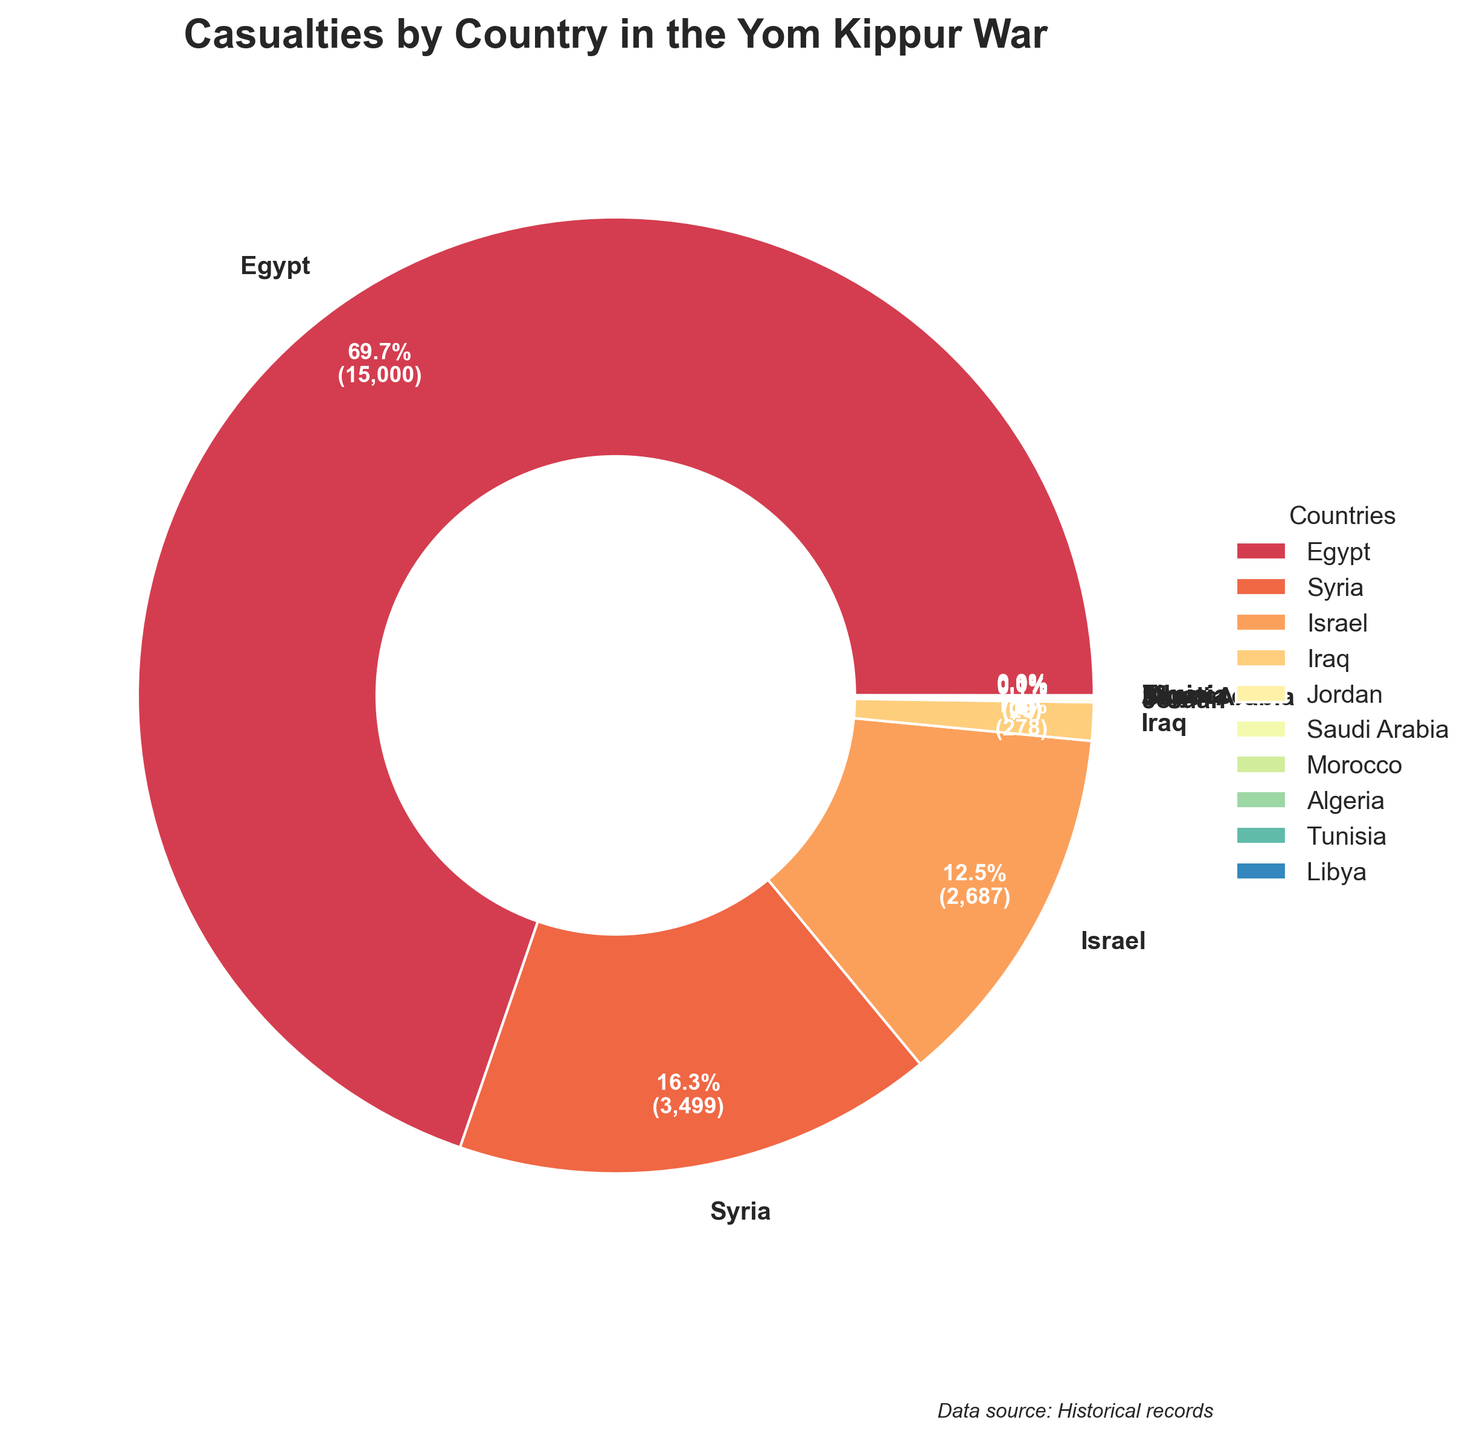Which country had the highest number of casualties? By looking at the pie chart, the largest segment should correspond to the country with the most casualties. The largest segment is labeled "Egypt."
Answer: Egypt How many more casualties did Syria have compared to Iraq? The pie chart shows Syria had 3,500 casualties, and Iraq had 278 casualties. To find the difference, subtract the number of casualties of Iraq from those of Syria: 3,500 - 278 = 3,222.
Answer: 3,222 What's the combined percentage of casualties from Israel and Syria? From the pie chart, Israel had 2,688 casualties, and Syria had 3,500 casualties. Adding them together: 2,688 + 3,500 = 6,188. The total casualties are 21,515. To find the combined percentage: (6,188 / 21,515) * 100 ≈ 28.8%.
Answer: 28.8% What is the percentage of casualties from Iraq? The pie chart displays percentages. Locate Iraq's segment, which shows the percentage directly. Iraq’s segment shows 1.3%.
Answer: 1.3% Which country contributed the least number of casualties, and how many? Refer to the smallest segment in the pie chart. The smallest segment is labeled "Libya," and it has 2 casualties.
Answer: Libya, 2 Which country had fewer casualties, Jordan or Algeria? Compare the sizes of the segments labeled "Jordan" and "Algeria". Jordan had 23 casualties, while Algeria had 5 casualties.
Answer: Algeria How does the percentage of Saudi Arabia’s casualties compare to that of Morocco’s? Locate the segments for "Saudi Arabia" and "Morocco" and compare their percentages. Saudi Arabia had a larger segment with 10 casualties compared to Morocco with 6 casualties, resulting in Saudi Arabia having a higher percentage.
Answer: Saudi Arabia What is the total percentage of casualties contributed by the countries with less than 100 casualties each? Identify the countries with less than 100 casualties directly from the chart: Jordan (23), Saudi Arabia (10), Morocco (6), Algeria (5), Tunisia (3), and Libya (2). Sum their casualties: 23 + 10 + 6 + 5 + 3 + 2 = 49. Calculate their percentage: (49 / 21,515) * 100 ≈ 0.2%.
Answer: 0.2% Which country had more casualties, Tunisia or Libya, and by how many? From the pie chart, Tunisia had 3 casualties, and Libya had 2 casualties. Find the difference: 3 - 2 = 1.
Answer: Tunisia, 1 By what factor is the number of casualties in Israel different from that in Iraq? Israel had 2,688 casualties, and Iraq had 278 casualties. Find the factor by dividing Israel’s casualties by Iraq’s: 2,688 / 278 ≈ 9.67.
Answer: 9.67 